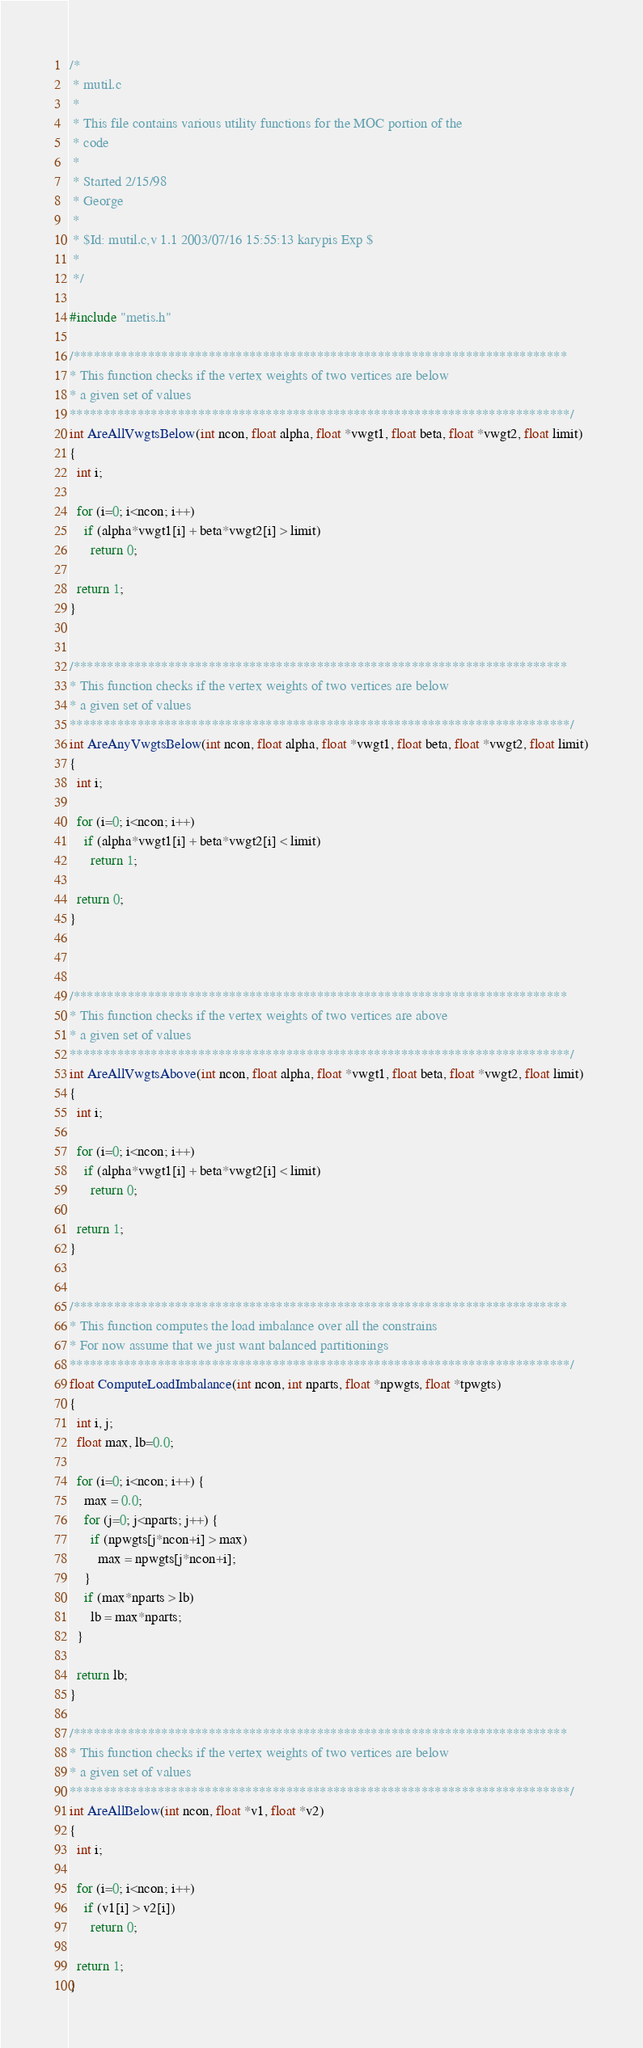<code> <loc_0><loc_0><loc_500><loc_500><_C_>/*
 * mutil.c 
 *
 * This file contains various utility functions for the MOC portion of the
 * code
 *
 * Started 2/15/98
 * George
 *
 * $Id: mutil.c,v 1.1 2003/07/16 15:55:13 karypis Exp $
 *
 */

#include "metis.h"

/*************************************************************************
* This function checks if the vertex weights of two vertices are below 
* a given set of values
**************************************************************************/
int AreAllVwgtsBelow(int ncon, float alpha, float *vwgt1, float beta, float *vwgt2, float limit)
{
  int i;

  for (i=0; i<ncon; i++)
    if (alpha*vwgt1[i] + beta*vwgt2[i] > limit)
      return 0;

  return 1;
}


/*************************************************************************
* This function checks if the vertex weights of two vertices are below 
* a given set of values
**************************************************************************/
int AreAnyVwgtsBelow(int ncon, float alpha, float *vwgt1, float beta, float *vwgt2, float limit)
{
  int i;

  for (i=0; i<ncon; i++)
    if (alpha*vwgt1[i] + beta*vwgt2[i] < limit)
      return 1;

  return 0;
}



/*************************************************************************
* This function checks if the vertex weights of two vertices are above 
* a given set of values
**************************************************************************/
int AreAllVwgtsAbove(int ncon, float alpha, float *vwgt1, float beta, float *vwgt2, float limit)
{
  int i;

  for (i=0; i<ncon; i++)
    if (alpha*vwgt1[i] + beta*vwgt2[i] < limit)
      return 0;

  return 1;
}


/*************************************************************************
* This function computes the load imbalance over all the constrains
* For now assume that we just want balanced partitionings
**************************************************************************/ 
float ComputeLoadImbalance(int ncon, int nparts, float *npwgts, float *tpwgts)
{
  int i, j;
  float max, lb=0.0;

  for (i=0; i<ncon; i++) {
    max = 0.0;
    for (j=0; j<nparts; j++) {
      if (npwgts[j*ncon+i] > max)
        max = npwgts[j*ncon+i];
    }
    if (max*nparts > lb)
      lb = max*nparts;
  }

  return lb;
}

/*************************************************************************
* This function checks if the vertex weights of two vertices are below 
* a given set of values
**************************************************************************/
int AreAllBelow(int ncon, float *v1, float *v2)
{
  int i;

  for (i=0; i<ncon; i++)
    if (v1[i] > v2[i])
      return 0;

  return 1;
}
</code> 